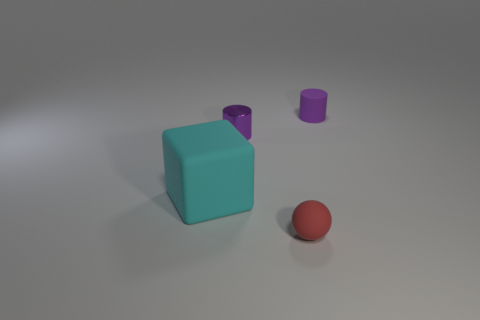Add 2 small purple cylinders. How many objects exist? 6 Subtract all spheres. How many objects are left? 3 Add 1 purple matte cylinders. How many purple matte cylinders are left? 2 Add 2 large yellow metal balls. How many large yellow metal balls exist? 2 Subtract 0 blue cylinders. How many objects are left? 4 Subtract all cyan matte things. Subtract all purple shiny cylinders. How many objects are left? 2 